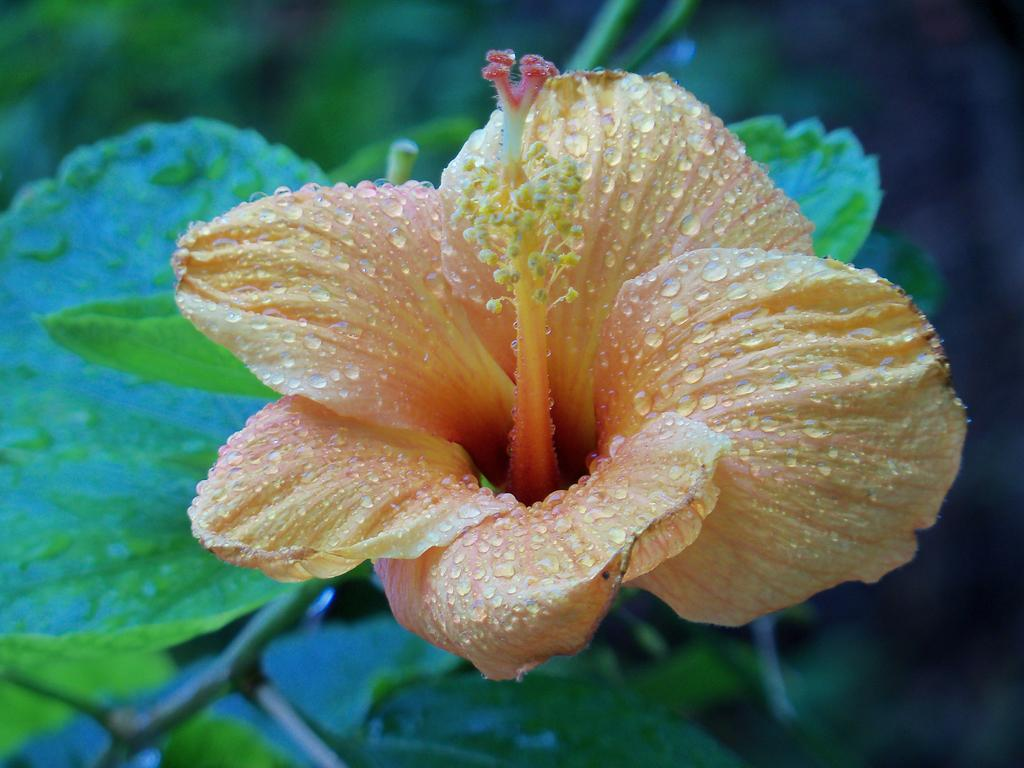What type of plant is visible in the image? There is a plant in the image, and it has flowers and leaves. What can be seen on the flowers and leaves of the plant? There are water drops on the flowers and leaves of the plant. How would you describe the background of the image? The background of the image is blurred. What type of advertisement can be seen on the ocean in the image? There is no advertisement or ocean present in the image; it features a plant with flowers and leaves, and a blurred background. 